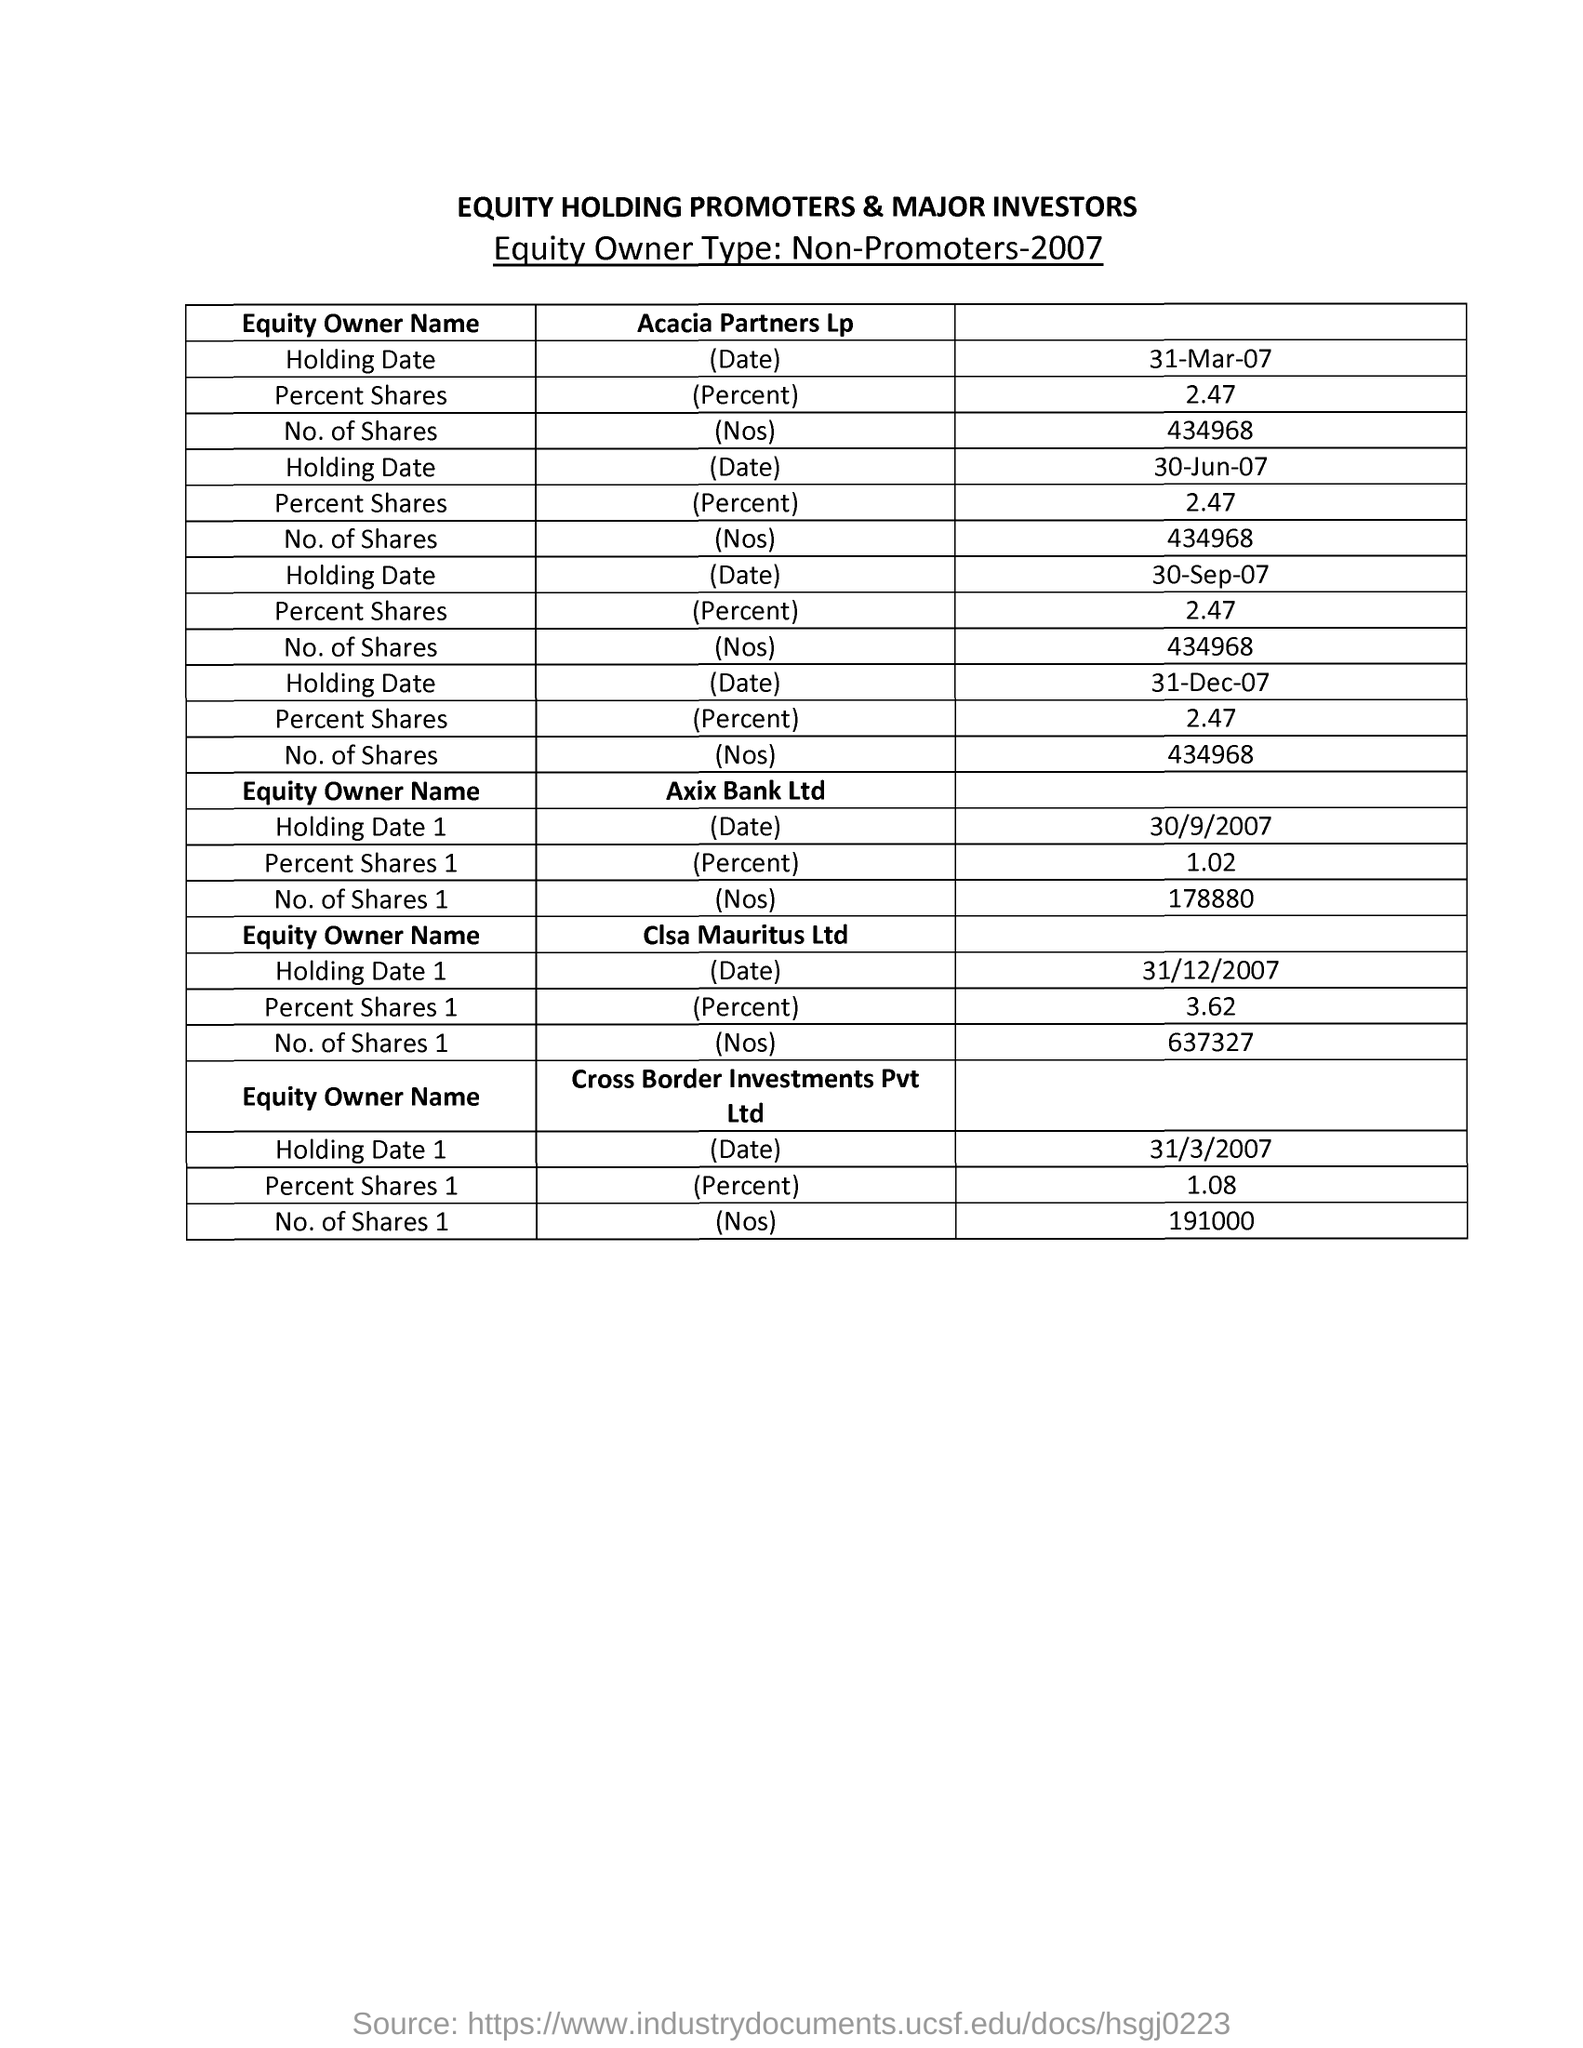Draw attention to some important aspects in this diagram. The document heading is "Equity Holding Promoters & Major Investors". 